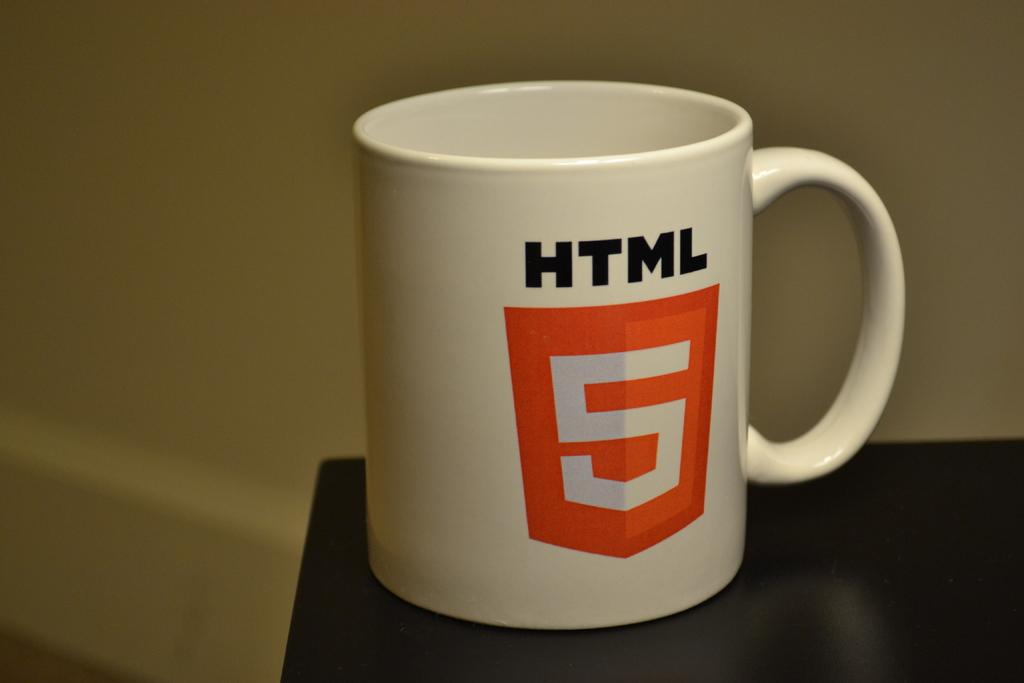<image>
Provide a brief description of the given image. A white coffee mug has a red 5 on it and says HTML. 